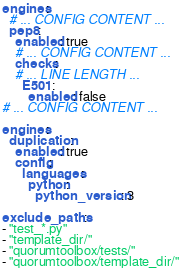<code> <loc_0><loc_0><loc_500><loc_500><_YAML_>engines:
  # ... CONFIG CONTENT ...
  pep8:
    enabled: true
    # ... CONFIG CONTENT ...
    checks:
    # ... LINE LENGTH ...
      E501:
        enabled: false
# ... CONFIG CONTENT ...

engines:
  duplication:
    enabled: true
    config:
      languages:
        python:
          python_version: 3

exclude_paths:
- "test_*.py"
- "template_dir/"
- "quorumtoolbox/tests/"
- "quorumtoolbox/template_dir/"
</code> 